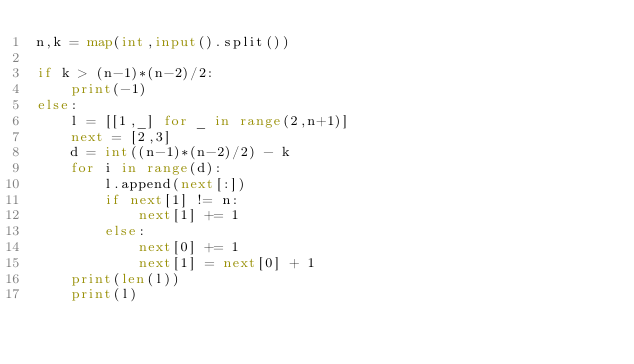Convert code to text. <code><loc_0><loc_0><loc_500><loc_500><_Python_>n,k = map(int,input().split())

if k > (n-1)*(n-2)/2:
    print(-1)
else:
    l = [[1,_] for _ in range(2,n+1)]
    next = [2,3]
    d = int((n-1)*(n-2)/2) - k
    for i in range(d):
        l.append(next[:])
        if next[1] != n:
            next[1] += 1
        else:
            next[0] += 1
            next[1] = next[0] + 1
    print(len(l))
    print(l)
</code> 